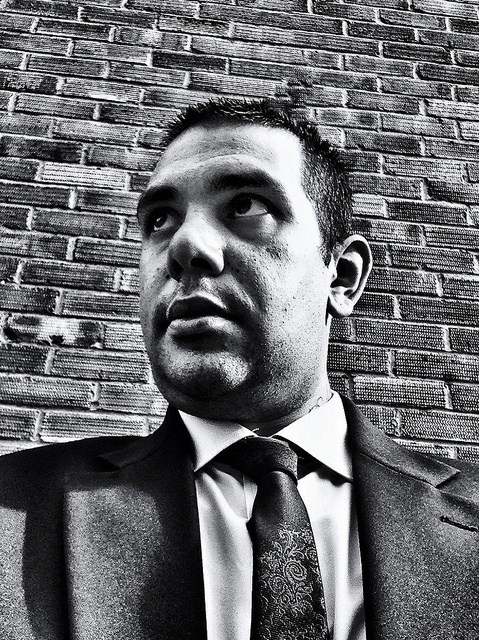Describe the objects in this image and their specific colors. I can see people in black, lightgray, gray, and darkgray tones and tie in black, gray, darkgray, and lightgray tones in this image. 